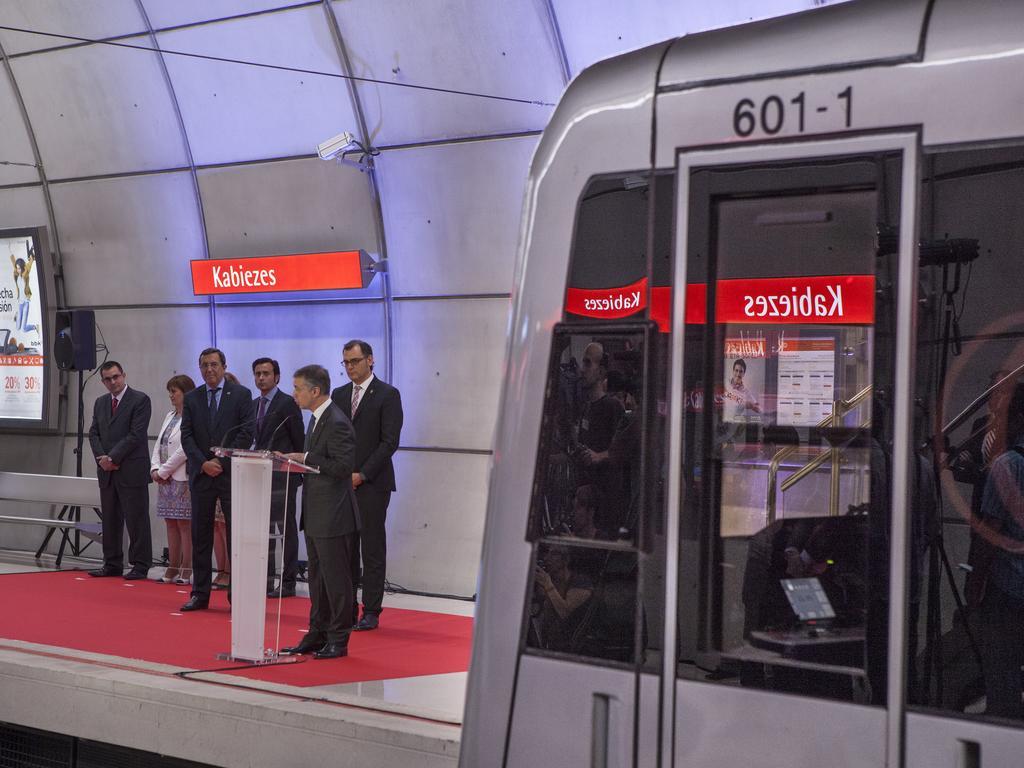How would you summarize this image in a sentence or two? In this picture there are group of people those who are standing on the left side of the image in front of a desk and a mic, there is a screen on the left side of the image and there is a bus on the right side of the image. 